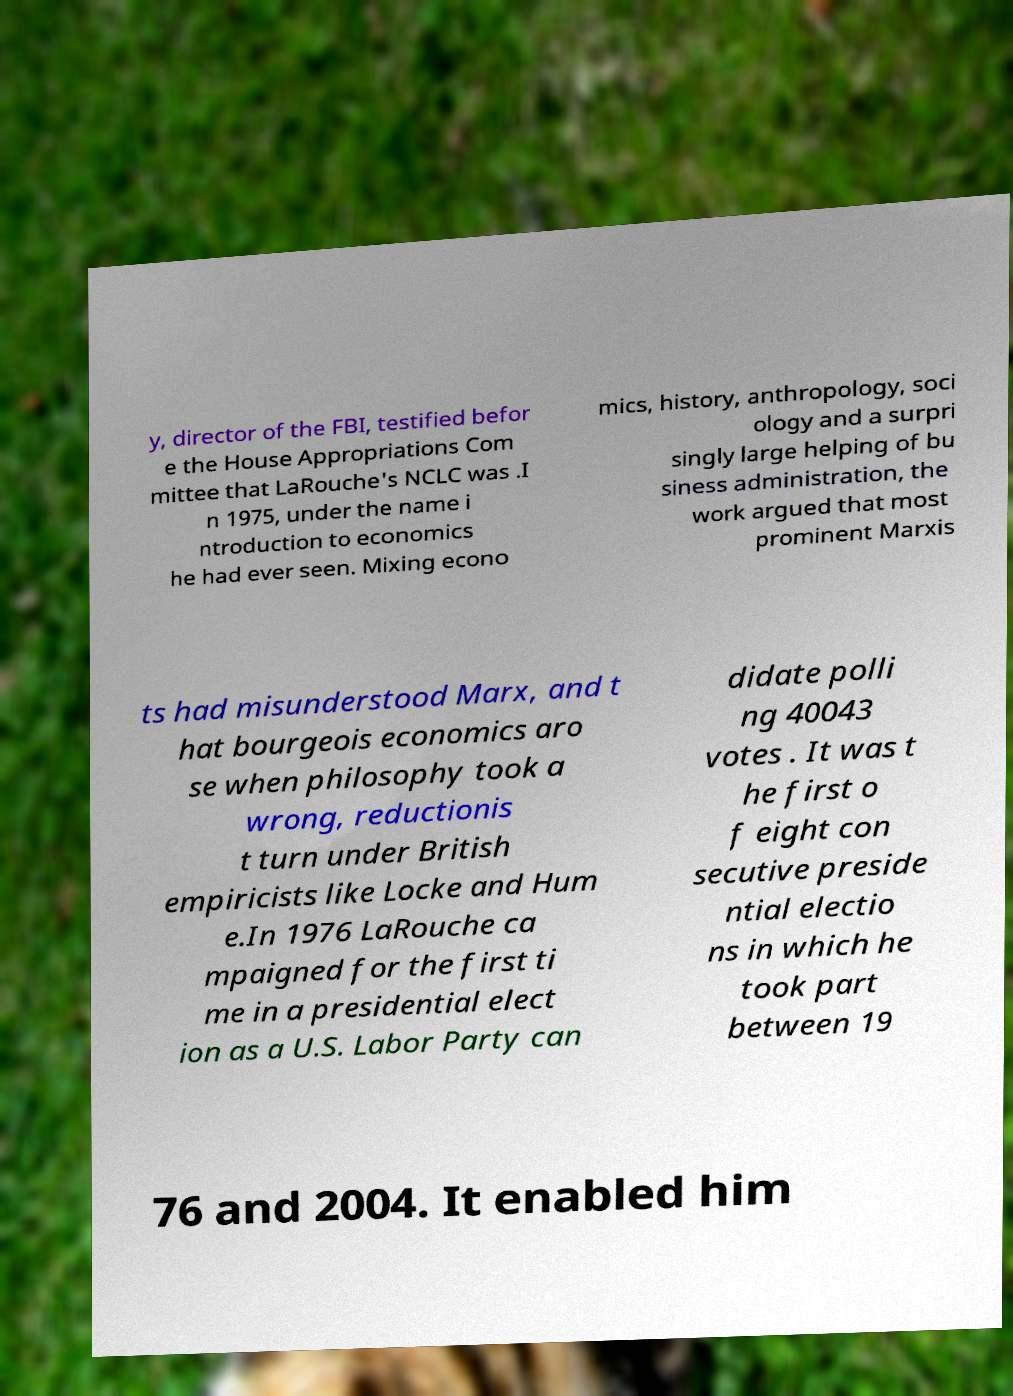There's text embedded in this image that I need extracted. Can you transcribe it verbatim? y, director of the FBI, testified befor e the House Appropriations Com mittee that LaRouche's NCLC was .I n 1975, under the name i ntroduction to economics he had ever seen. Mixing econo mics, history, anthropology, soci ology and a surpri singly large helping of bu siness administration, the work argued that most prominent Marxis ts had misunderstood Marx, and t hat bourgeois economics aro se when philosophy took a wrong, reductionis t turn under British empiricists like Locke and Hum e.In 1976 LaRouche ca mpaigned for the first ti me in a presidential elect ion as a U.S. Labor Party can didate polli ng 40043 votes . It was t he first o f eight con secutive preside ntial electio ns in which he took part between 19 76 and 2004. It enabled him 